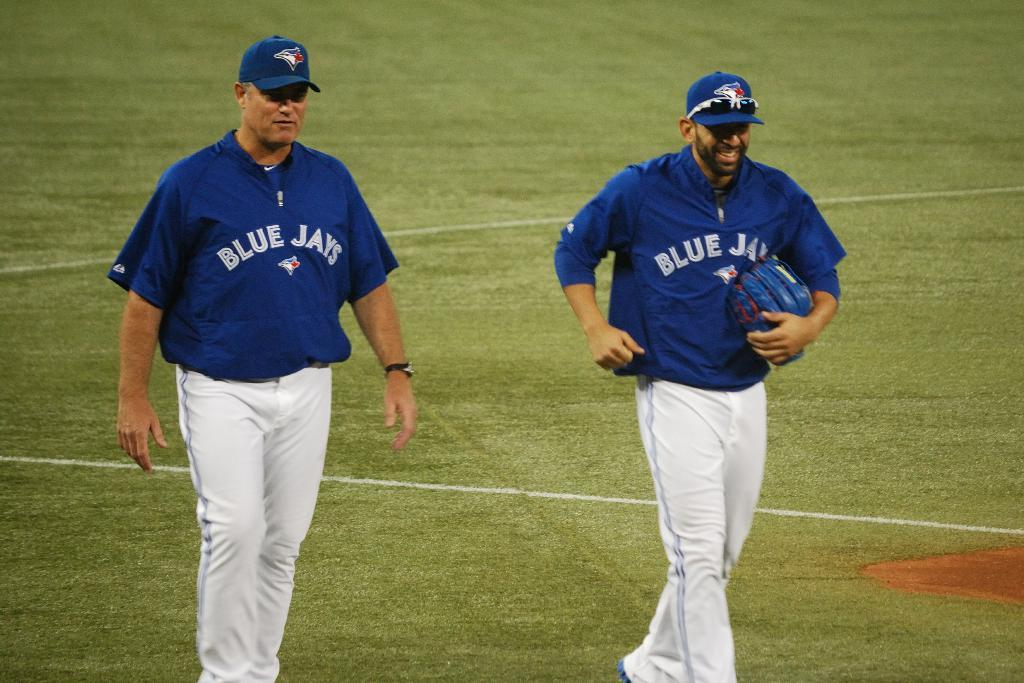<image>
Provide a brief description of the given image. Two Blue Jays players walks on the baseball field with one carrying a mitt. 